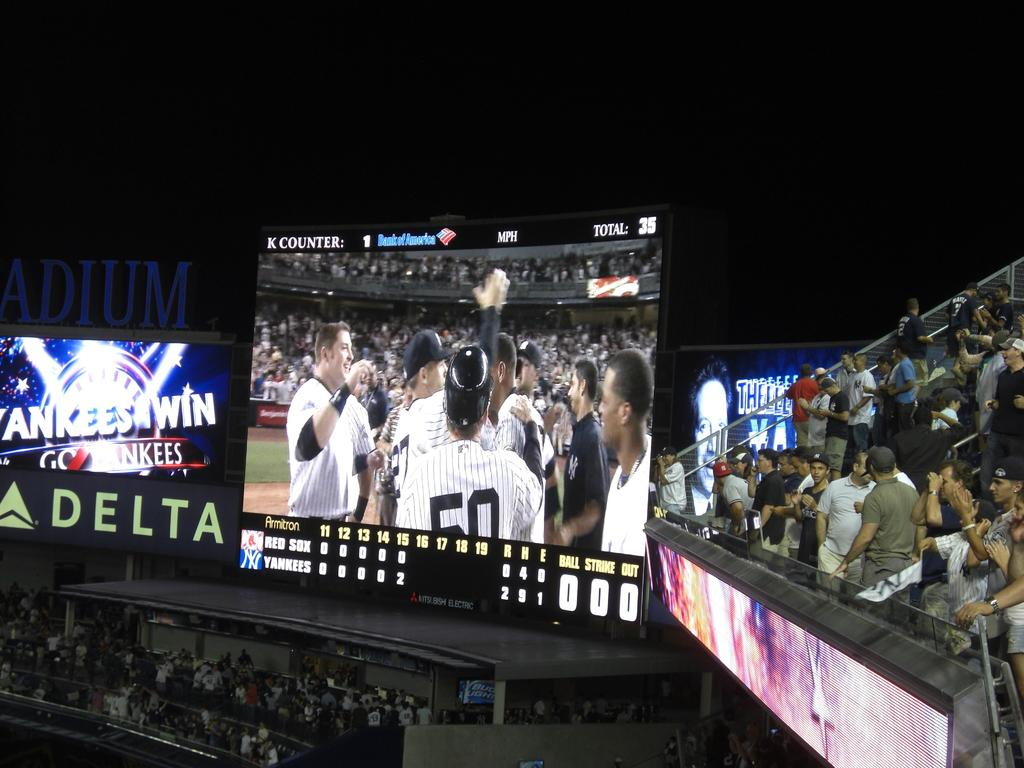Provide a one-sentence caption for the provided image. a baseball stadium screen at night with the game below, signage says Yankees Win with Delta advertised underneath. 